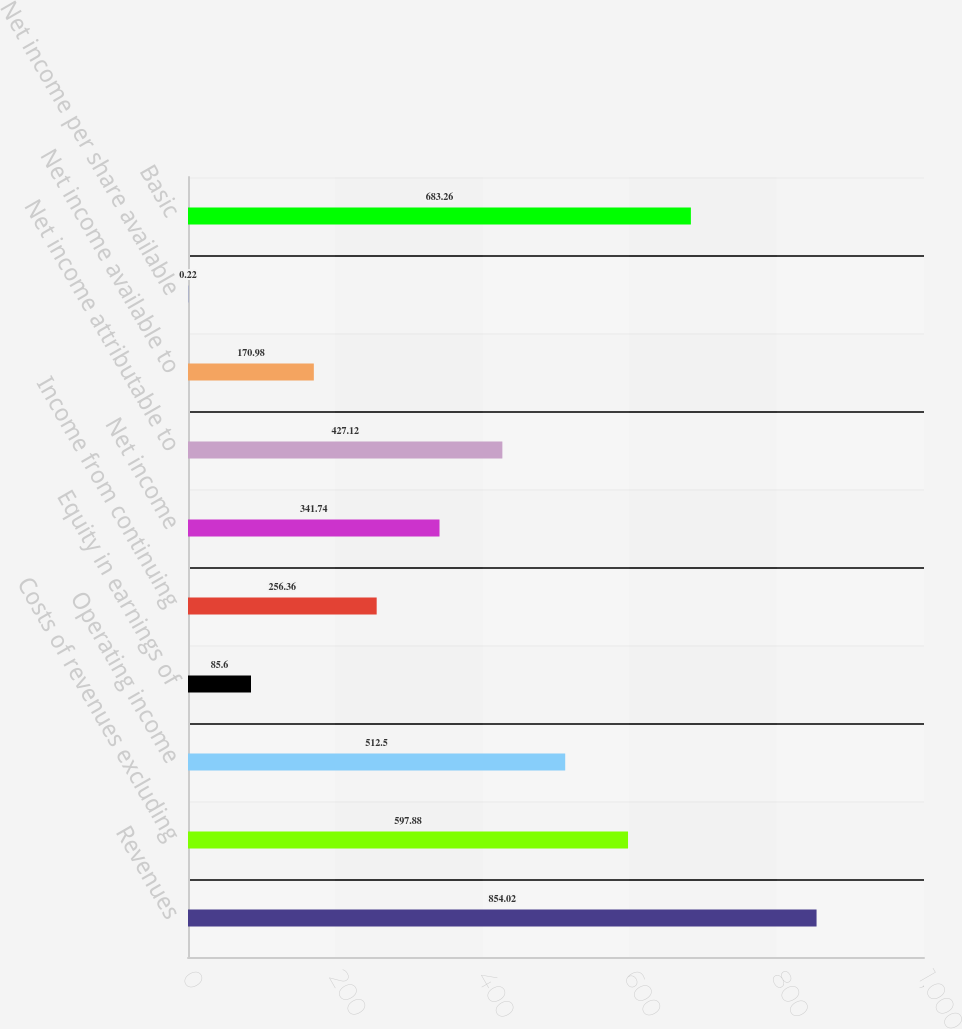Convert chart to OTSL. <chart><loc_0><loc_0><loc_500><loc_500><bar_chart><fcel>Revenues<fcel>Costs of revenues excluding<fcel>Operating income<fcel>Equity in earnings of<fcel>Income from continuing<fcel>Net income<fcel>Net income attributable to<fcel>Net income available to<fcel>Net income per share available<fcel>Basic<nl><fcel>854.02<fcel>597.88<fcel>512.5<fcel>85.6<fcel>256.36<fcel>341.74<fcel>427.12<fcel>170.98<fcel>0.22<fcel>683.26<nl></chart> 